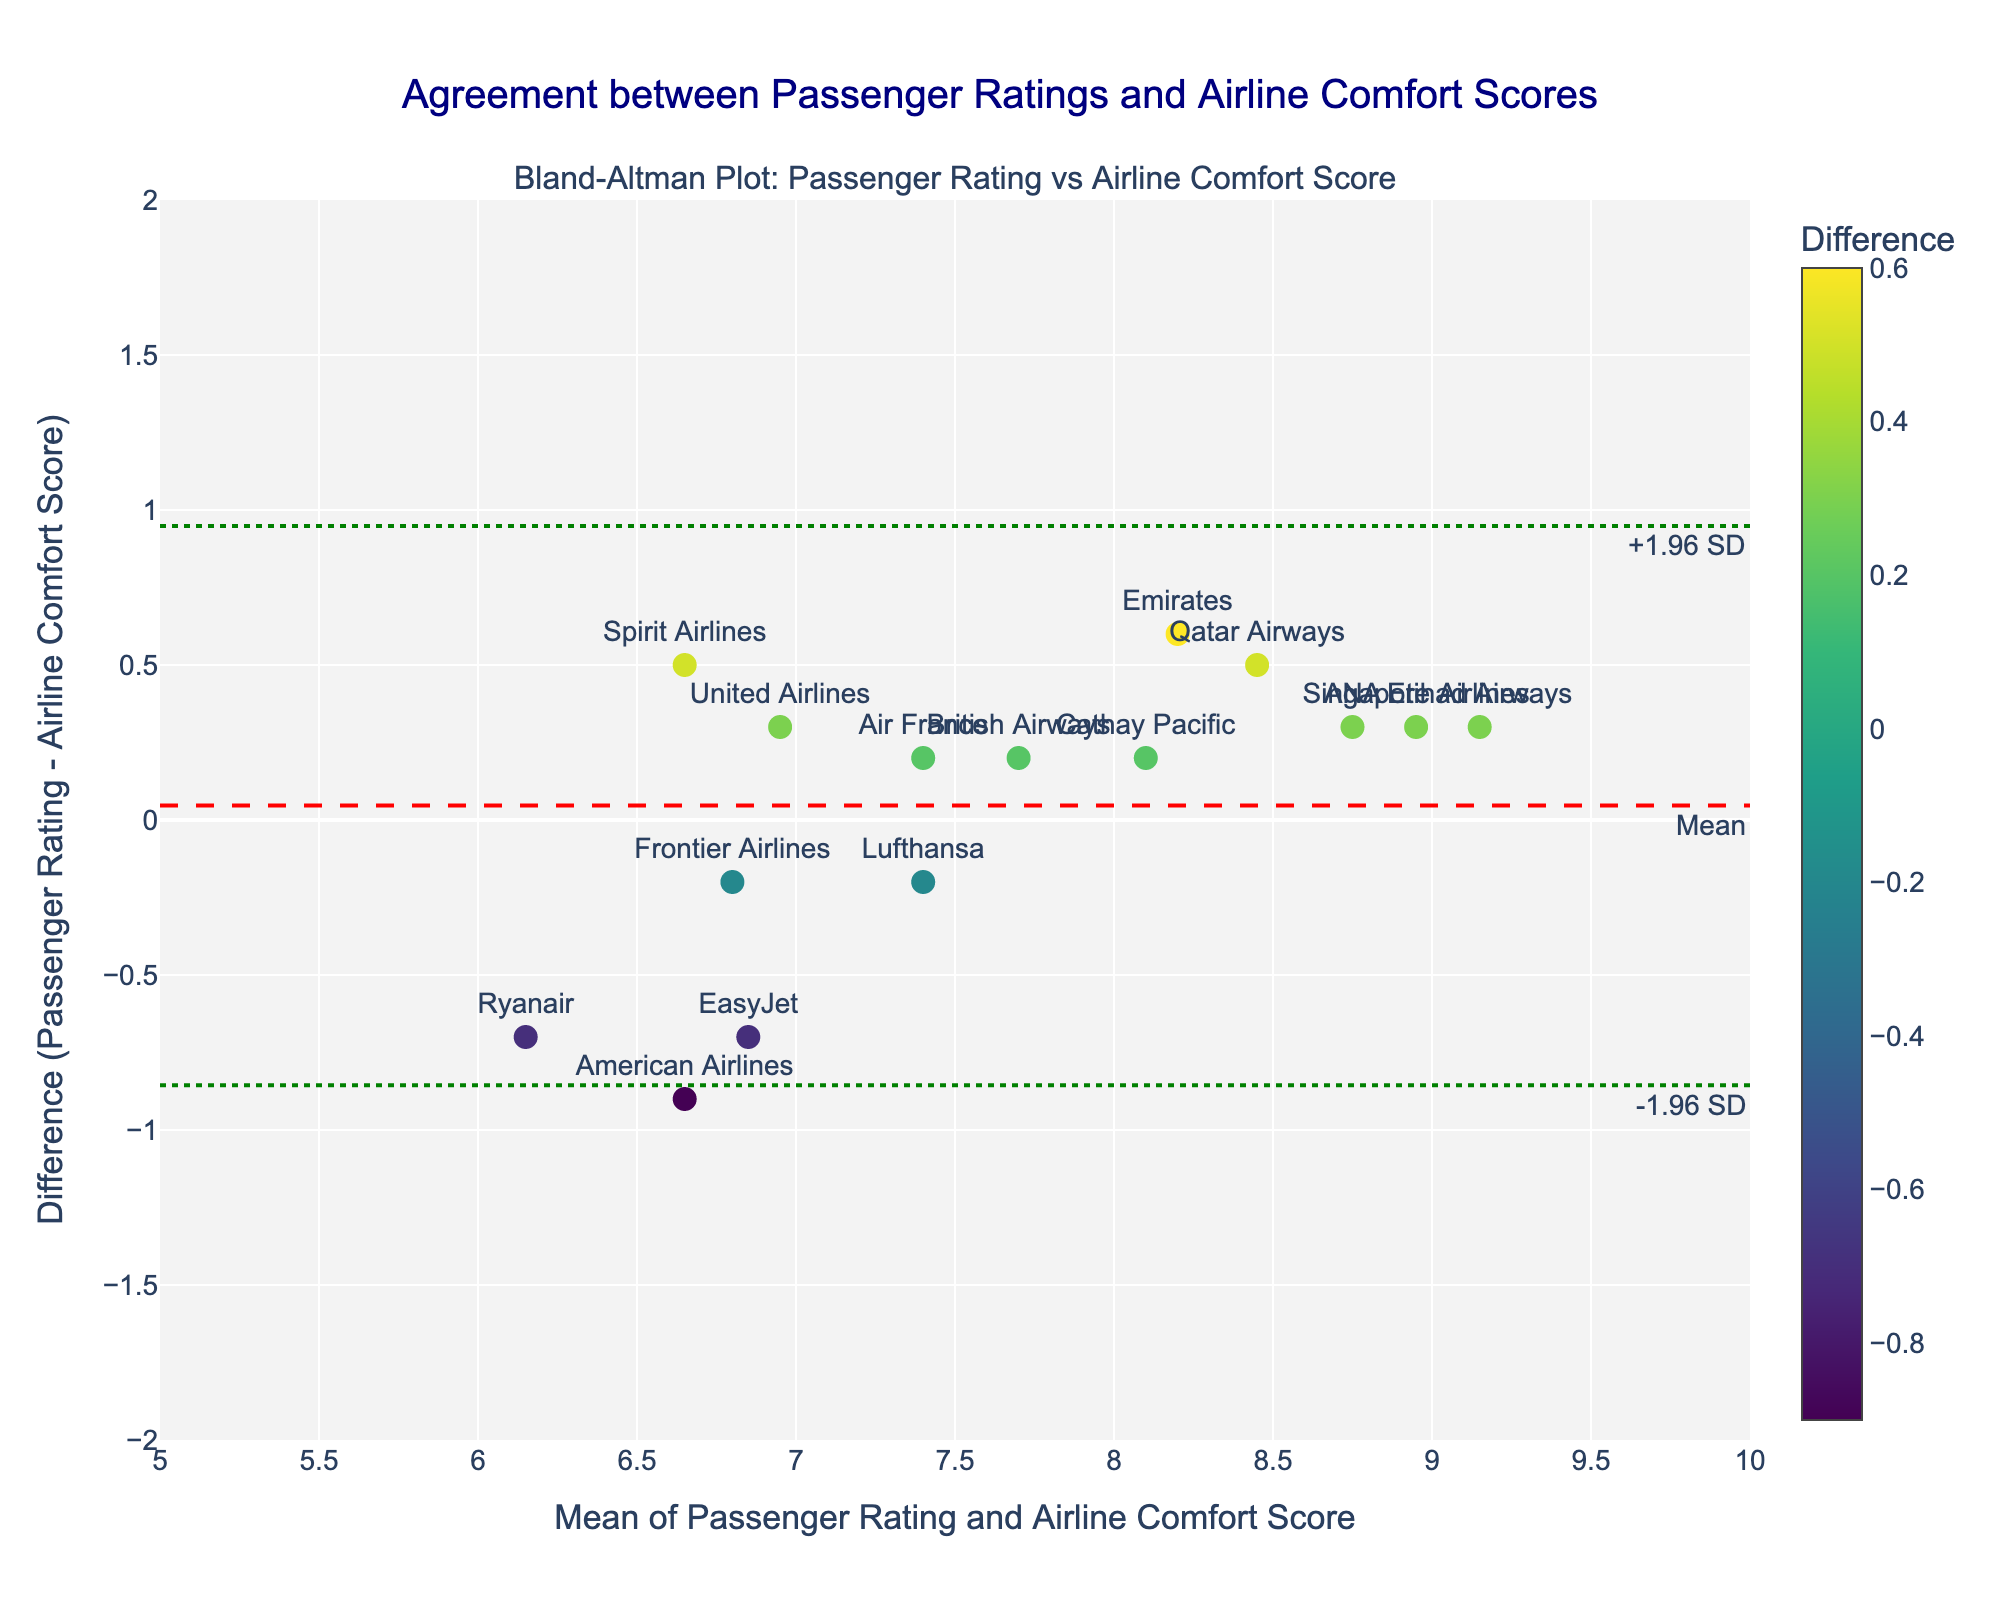Which airline has the largest difference between passenger rating and airline comfort score? By looking at the vertical (y-axis) distance from the mean difference line, we can identify the data point with the largest absolute difference.
Answer: Ryanair What is the general trend of the data points in the Bland-Altman plot? Most data points are clustered around the mean difference line with only a few outliers beyond the limits of agreement lines. This indicates a general agreement between passenger ratings and airline comfort scores.
Answer: General agreement with few outliers What is the mean difference between passenger ratings and airline comfort scores? The mean difference is marked by the red dashed line on the y-axis. The value can be directly observed from the figure around the y-axis.
Answer: Approximately 0.3 Which airline has the smallest difference between passenger rating and airline comfort score? Identify the data point closest to the mean difference line.
Answer: Lufthansa Are any data points outside the limits of agreement? If so, which airlines? The green dotted lines (upper and lower limits of agreement) indicate the acceptable range. Find data points above or below these lines.
Answer: No data points outside limits How are the differences between passenger ratings and airline comfort scores distributed across airlines? Markers' positions between the limits of agreement show that most differences are within ±1.
Answer: Most differences within ±1 Which airline has a passenger rating equal to the average of all the rated airlines? Calculate the mean of all passenger ratings and identify the airline closest to this rate on the x-axis.
Answer: Lufthansa Is there any airline whose passenger rating almost perfectly matches the comfort score provided by the airline? The data point where the y-value is closest to zero indicates the smallest difference between passenger rating and comfort score.
Answer: British Airways What can be inferred about airlines whose points lie above the mean difference line compared to those below? Points above the mean line suggest higher passenger ratings than airline comfort scores, whereas those below suggest lower passenger ratings.
Answer: Passengers rated higher/lower than airline comfort Which airline has the highest mean of passenger rating and airline comfort score? Identify the data point furthest to the right on the x-axis (mean) for passenger rating and comfort scores.
Answer: Etihad Airways 